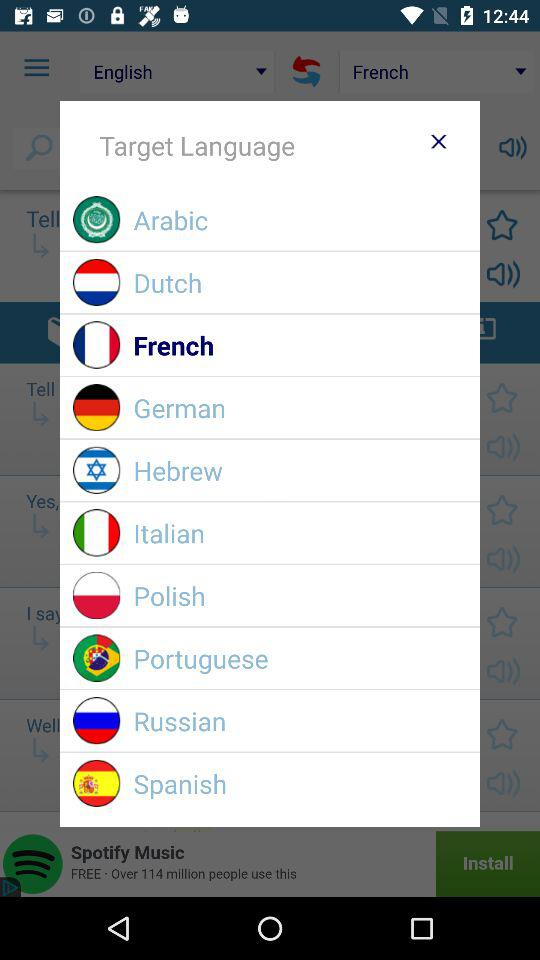Which option is selected? The selected option is "French". 